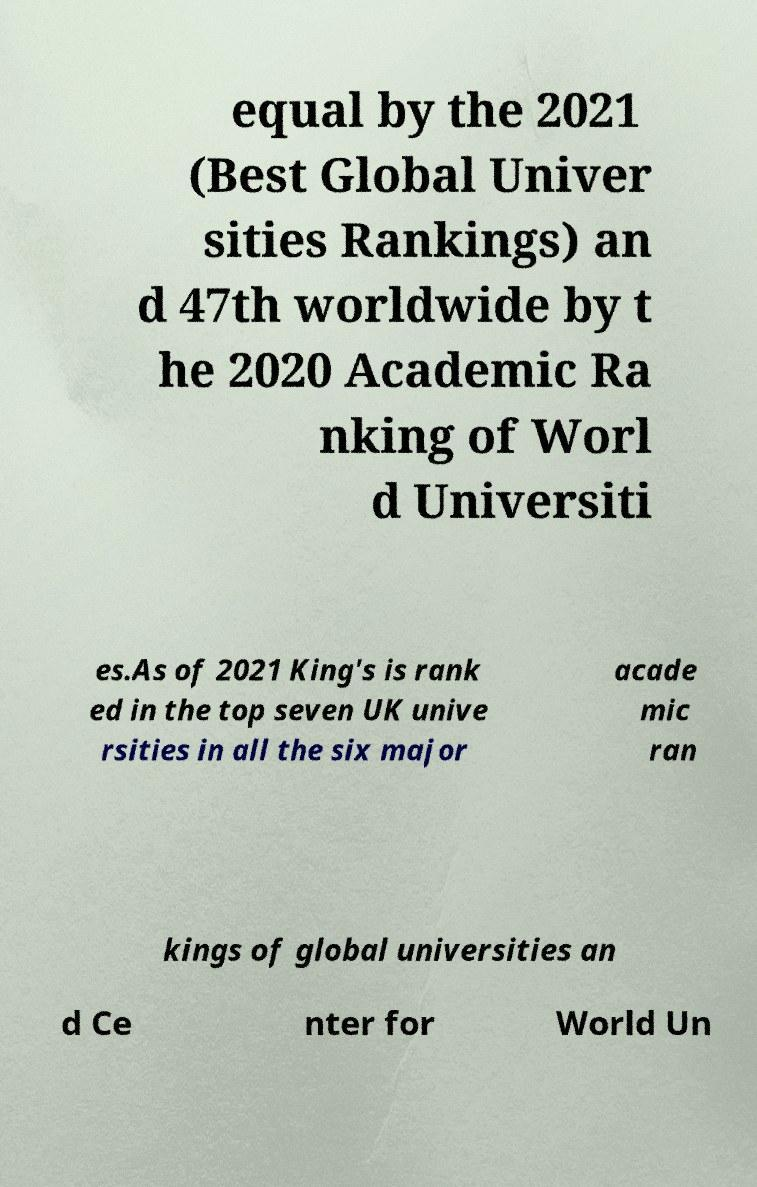Can you read and provide the text displayed in the image?This photo seems to have some interesting text. Can you extract and type it out for me? equal by the 2021 (Best Global Univer sities Rankings) an d 47th worldwide by t he 2020 Academic Ra nking of Worl d Universiti es.As of 2021 King's is rank ed in the top seven UK unive rsities in all the six major acade mic ran kings of global universities an d Ce nter for World Un 